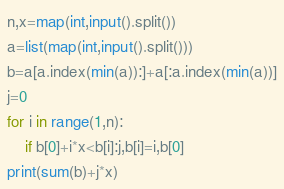Convert code to text. <code><loc_0><loc_0><loc_500><loc_500><_Python_>n,x=map(int,input().split())
a=list(map(int,input().split()))
b=a[a.index(min(a)):]+a[:a.index(min(a))]
j=0
for i in range(1,n):
    if b[0]+i*x<b[i]:j,b[i]=i,b[0]
print(sum(b)+j*x)</code> 